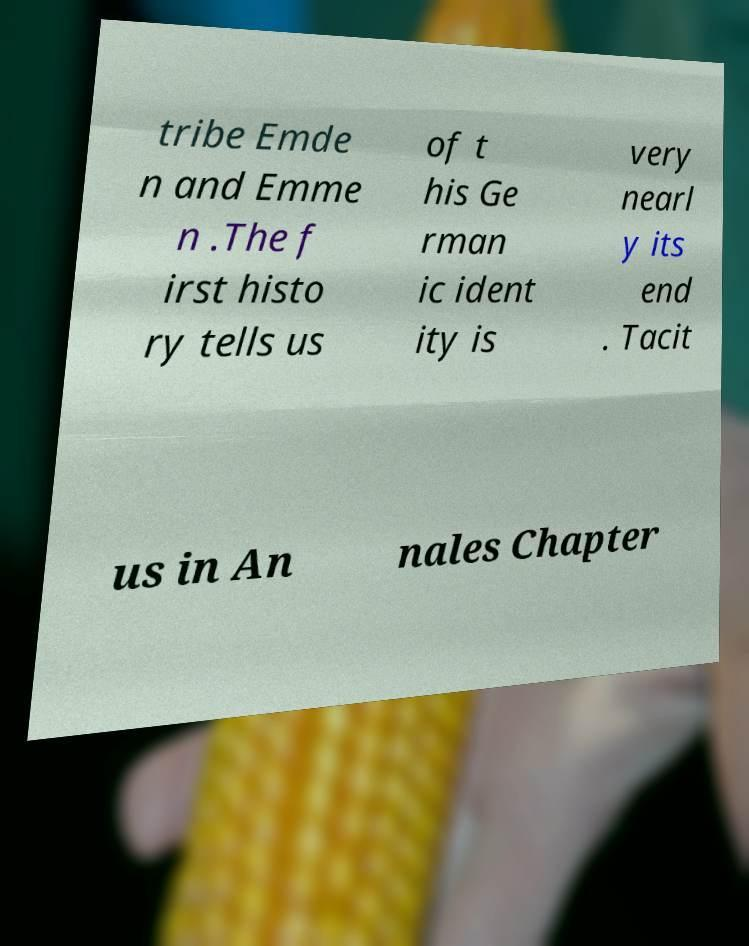Could you extract and type out the text from this image? tribe Emde n and Emme n .The f irst histo ry tells us of t his Ge rman ic ident ity is very nearl y its end . Tacit us in An nales Chapter 